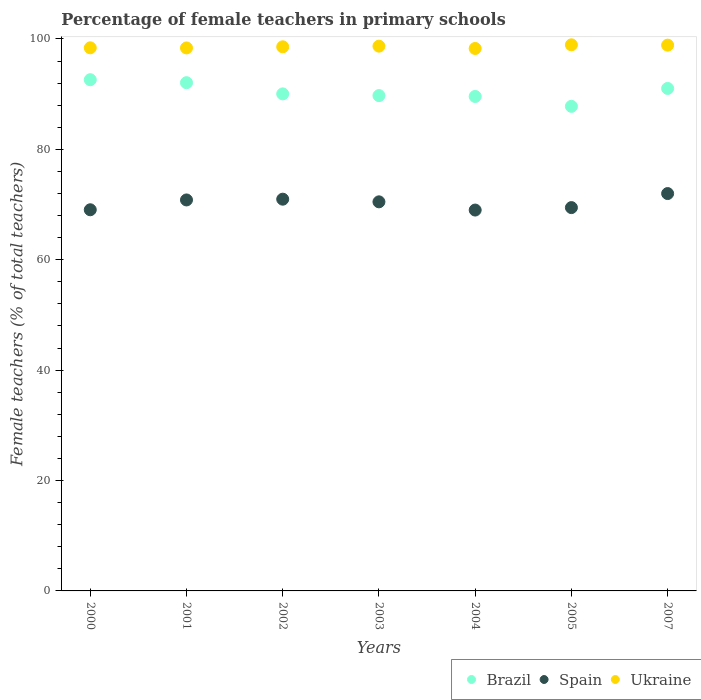How many different coloured dotlines are there?
Keep it short and to the point. 3. What is the percentage of female teachers in Brazil in 2002?
Offer a terse response. 90.04. Across all years, what is the maximum percentage of female teachers in Ukraine?
Offer a very short reply. 98.93. Across all years, what is the minimum percentage of female teachers in Brazil?
Provide a succinct answer. 87.79. In which year was the percentage of female teachers in Ukraine minimum?
Provide a succinct answer. 2004. What is the total percentage of female teachers in Brazil in the graph?
Make the answer very short. 632.86. What is the difference between the percentage of female teachers in Brazil in 2002 and that in 2003?
Provide a short and direct response. 0.31. What is the difference between the percentage of female teachers in Spain in 2004 and the percentage of female teachers in Ukraine in 2001?
Provide a short and direct response. -29.37. What is the average percentage of female teachers in Brazil per year?
Ensure brevity in your answer.  90.41. In the year 2004, what is the difference between the percentage of female teachers in Brazil and percentage of female teachers in Ukraine?
Your response must be concise. -8.69. What is the ratio of the percentage of female teachers in Brazil in 2005 to that in 2007?
Offer a very short reply. 0.96. Is the percentage of female teachers in Spain in 2002 less than that in 2004?
Offer a very short reply. No. What is the difference between the highest and the second highest percentage of female teachers in Brazil?
Your response must be concise. 0.54. What is the difference between the highest and the lowest percentage of female teachers in Spain?
Provide a short and direct response. 2.99. In how many years, is the percentage of female teachers in Spain greater than the average percentage of female teachers in Spain taken over all years?
Provide a succinct answer. 4. Is it the case that in every year, the sum of the percentage of female teachers in Spain and percentage of female teachers in Ukraine  is greater than the percentage of female teachers in Brazil?
Ensure brevity in your answer.  Yes. Is the percentage of female teachers in Spain strictly less than the percentage of female teachers in Brazil over the years?
Your response must be concise. Yes. What is the difference between two consecutive major ticks on the Y-axis?
Give a very brief answer. 20. Are the values on the major ticks of Y-axis written in scientific E-notation?
Provide a succinct answer. No. Does the graph contain any zero values?
Keep it short and to the point. No. How are the legend labels stacked?
Your answer should be compact. Horizontal. What is the title of the graph?
Make the answer very short. Percentage of female teachers in primary schools. Does "Cameroon" appear as one of the legend labels in the graph?
Keep it short and to the point. No. What is the label or title of the Y-axis?
Your answer should be very brief. Female teachers (% of total teachers). What is the Female teachers (% of total teachers) in Brazil in 2000?
Make the answer very short. 92.61. What is the Female teachers (% of total teachers) in Spain in 2000?
Keep it short and to the point. 69.05. What is the Female teachers (% of total teachers) of Ukraine in 2000?
Your answer should be very brief. 98.39. What is the Female teachers (% of total teachers) of Brazil in 2001?
Provide a succinct answer. 92.07. What is the Female teachers (% of total teachers) in Spain in 2001?
Provide a short and direct response. 70.83. What is the Female teachers (% of total teachers) of Ukraine in 2001?
Make the answer very short. 98.37. What is the Female teachers (% of total teachers) in Brazil in 2002?
Provide a short and direct response. 90.04. What is the Female teachers (% of total teachers) in Spain in 2002?
Give a very brief answer. 70.97. What is the Female teachers (% of total teachers) of Ukraine in 2002?
Your response must be concise. 98.57. What is the Female teachers (% of total teachers) in Brazil in 2003?
Your answer should be compact. 89.73. What is the Female teachers (% of total teachers) of Spain in 2003?
Provide a short and direct response. 70.49. What is the Female teachers (% of total teachers) in Ukraine in 2003?
Make the answer very short. 98.69. What is the Female teachers (% of total teachers) of Brazil in 2004?
Your answer should be very brief. 89.58. What is the Female teachers (% of total teachers) in Spain in 2004?
Provide a short and direct response. 69. What is the Female teachers (% of total teachers) of Ukraine in 2004?
Make the answer very short. 98.27. What is the Female teachers (% of total teachers) in Brazil in 2005?
Your response must be concise. 87.79. What is the Female teachers (% of total teachers) in Spain in 2005?
Your response must be concise. 69.44. What is the Female teachers (% of total teachers) of Ukraine in 2005?
Offer a terse response. 98.93. What is the Female teachers (% of total teachers) of Brazil in 2007?
Ensure brevity in your answer.  91.03. What is the Female teachers (% of total teachers) of Spain in 2007?
Provide a succinct answer. 71.99. What is the Female teachers (% of total teachers) of Ukraine in 2007?
Keep it short and to the point. 98.87. Across all years, what is the maximum Female teachers (% of total teachers) in Brazil?
Your answer should be compact. 92.61. Across all years, what is the maximum Female teachers (% of total teachers) in Spain?
Your response must be concise. 71.99. Across all years, what is the maximum Female teachers (% of total teachers) of Ukraine?
Offer a terse response. 98.93. Across all years, what is the minimum Female teachers (% of total teachers) of Brazil?
Ensure brevity in your answer.  87.79. Across all years, what is the minimum Female teachers (% of total teachers) in Spain?
Offer a very short reply. 69. Across all years, what is the minimum Female teachers (% of total teachers) of Ukraine?
Your answer should be compact. 98.27. What is the total Female teachers (% of total teachers) of Brazil in the graph?
Your answer should be very brief. 632.86. What is the total Female teachers (% of total teachers) in Spain in the graph?
Provide a short and direct response. 491.76. What is the total Female teachers (% of total teachers) of Ukraine in the graph?
Your response must be concise. 690.09. What is the difference between the Female teachers (% of total teachers) of Brazil in 2000 and that in 2001?
Ensure brevity in your answer.  0.54. What is the difference between the Female teachers (% of total teachers) in Spain in 2000 and that in 2001?
Make the answer very short. -1.78. What is the difference between the Female teachers (% of total teachers) in Ukraine in 2000 and that in 2001?
Ensure brevity in your answer.  0.02. What is the difference between the Female teachers (% of total teachers) of Brazil in 2000 and that in 2002?
Ensure brevity in your answer.  2.57. What is the difference between the Female teachers (% of total teachers) of Spain in 2000 and that in 2002?
Keep it short and to the point. -1.92. What is the difference between the Female teachers (% of total teachers) of Ukraine in 2000 and that in 2002?
Your answer should be very brief. -0.18. What is the difference between the Female teachers (% of total teachers) in Brazil in 2000 and that in 2003?
Make the answer very short. 2.88. What is the difference between the Female teachers (% of total teachers) in Spain in 2000 and that in 2003?
Offer a terse response. -1.44. What is the difference between the Female teachers (% of total teachers) in Ukraine in 2000 and that in 2003?
Ensure brevity in your answer.  -0.3. What is the difference between the Female teachers (% of total teachers) in Brazil in 2000 and that in 2004?
Offer a terse response. 3.03. What is the difference between the Female teachers (% of total teachers) of Spain in 2000 and that in 2004?
Keep it short and to the point. 0.05. What is the difference between the Female teachers (% of total teachers) of Ukraine in 2000 and that in 2004?
Your response must be concise. 0.12. What is the difference between the Female teachers (% of total teachers) of Brazil in 2000 and that in 2005?
Your answer should be very brief. 4.83. What is the difference between the Female teachers (% of total teachers) of Spain in 2000 and that in 2005?
Make the answer very short. -0.39. What is the difference between the Female teachers (% of total teachers) of Ukraine in 2000 and that in 2005?
Keep it short and to the point. -0.54. What is the difference between the Female teachers (% of total teachers) of Brazil in 2000 and that in 2007?
Offer a terse response. 1.58. What is the difference between the Female teachers (% of total teachers) of Spain in 2000 and that in 2007?
Offer a terse response. -2.94. What is the difference between the Female teachers (% of total teachers) of Ukraine in 2000 and that in 2007?
Offer a very short reply. -0.48. What is the difference between the Female teachers (% of total teachers) in Brazil in 2001 and that in 2002?
Make the answer very short. 2.03. What is the difference between the Female teachers (% of total teachers) of Spain in 2001 and that in 2002?
Provide a short and direct response. -0.14. What is the difference between the Female teachers (% of total teachers) of Ukraine in 2001 and that in 2002?
Make the answer very short. -0.2. What is the difference between the Female teachers (% of total teachers) of Brazil in 2001 and that in 2003?
Provide a short and direct response. 2.34. What is the difference between the Female teachers (% of total teachers) in Spain in 2001 and that in 2003?
Provide a short and direct response. 0.34. What is the difference between the Female teachers (% of total teachers) in Ukraine in 2001 and that in 2003?
Your answer should be compact. -0.32. What is the difference between the Female teachers (% of total teachers) of Brazil in 2001 and that in 2004?
Give a very brief answer. 2.49. What is the difference between the Female teachers (% of total teachers) of Spain in 2001 and that in 2004?
Provide a short and direct response. 1.83. What is the difference between the Female teachers (% of total teachers) of Ukraine in 2001 and that in 2004?
Offer a terse response. 0.1. What is the difference between the Female teachers (% of total teachers) in Brazil in 2001 and that in 2005?
Offer a very short reply. 4.28. What is the difference between the Female teachers (% of total teachers) in Spain in 2001 and that in 2005?
Make the answer very short. 1.39. What is the difference between the Female teachers (% of total teachers) of Ukraine in 2001 and that in 2005?
Keep it short and to the point. -0.56. What is the difference between the Female teachers (% of total teachers) in Brazil in 2001 and that in 2007?
Keep it short and to the point. 1.04. What is the difference between the Female teachers (% of total teachers) in Spain in 2001 and that in 2007?
Give a very brief answer. -1.16. What is the difference between the Female teachers (% of total teachers) in Ukraine in 2001 and that in 2007?
Provide a short and direct response. -0.5. What is the difference between the Female teachers (% of total teachers) of Brazil in 2002 and that in 2003?
Provide a short and direct response. 0.31. What is the difference between the Female teachers (% of total teachers) of Spain in 2002 and that in 2003?
Provide a succinct answer. 0.48. What is the difference between the Female teachers (% of total teachers) of Ukraine in 2002 and that in 2003?
Give a very brief answer. -0.12. What is the difference between the Female teachers (% of total teachers) of Brazil in 2002 and that in 2004?
Offer a terse response. 0.47. What is the difference between the Female teachers (% of total teachers) in Spain in 2002 and that in 2004?
Offer a very short reply. 1.97. What is the difference between the Female teachers (% of total teachers) of Ukraine in 2002 and that in 2004?
Provide a succinct answer. 0.3. What is the difference between the Female teachers (% of total teachers) in Brazil in 2002 and that in 2005?
Your answer should be compact. 2.26. What is the difference between the Female teachers (% of total teachers) of Spain in 2002 and that in 2005?
Your answer should be very brief. 1.53. What is the difference between the Female teachers (% of total teachers) in Ukraine in 2002 and that in 2005?
Provide a succinct answer. -0.36. What is the difference between the Female teachers (% of total teachers) in Brazil in 2002 and that in 2007?
Give a very brief answer. -0.99. What is the difference between the Female teachers (% of total teachers) of Spain in 2002 and that in 2007?
Give a very brief answer. -1.02. What is the difference between the Female teachers (% of total teachers) in Ukraine in 2002 and that in 2007?
Provide a short and direct response. -0.3. What is the difference between the Female teachers (% of total teachers) in Brazil in 2003 and that in 2004?
Ensure brevity in your answer.  0.16. What is the difference between the Female teachers (% of total teachers) of Spain in 2003 and that in 2004?
Your answer should be compact. 1.49. What is the difference between the Female teachers (% of total teachers) of Ukraine in 2003 and that in 2004?
Your response must be concise. 0.42. What is the difference between the Female teachers (% of total teachers) of Brazil in 2003 and that in 2005?
Give a very brief answer. 1.95. What is the difference between the Female teachers (% of total teachers) of Spain in 2003 and that in 2005?
Your answer should be compact. 1.04. What is the difference between the Female teachers (% of total teachers) in Ukraine in 2003 and that in 2005?
Give a very brief answer. -0.24. What is the difference between the Female teachers (% of total teachers) in Brazil in 2003 and that in 2007?
Your response must be concise. -1.3. What is the difference between the Female teachers (% of total teachers) of Spain in 2003 and that in 2007?
Offer a terse response. -1.5. What is the difference between the Female teachers (% of total teachers) in Ukraine in 2003 and that in 2007?
Keep it short and to the point. -0.18. What is the difference between the Female teachers (% of total teachers) of Brazil in 2004 and that in 2005?
Your response must be concise. 1.79. What is the difference between the Female teachers (% of total teachers) of Spain in 2004 and that in 2005?
Your answer should be very brief. -0.45. What is the difference between the Female teachers (% of total teachers) in Ukraine in 2004 and that in 2005?
Give a very brief answer. -0.66. What is the difference between the Female teachers (% of total teachers) of Brazil in 2004 and that in 2007?
Ensure brevity in your answer.  -1.45. What is the difference between the Female teachers (% of total teachers) in Spain in 2004 and that in 2007?
Offer a terse response. -2.99. What is the difference between the Female teachers (% of total teachers) in Ukraine in 2004 and that in 2007?
Give a very brief answer. -0.6. What is the difference between the Female teachers (% of total teachers) of Brazil in 2005 and that in 2007?
Ensure brevity in your answer.  -3.24. What is the difference between the Female teachers (% of total teachers) of Spain in 2005 and that in 2007?
Ensure brevity in your answer.  -2.54. What is the difference between the Female teachers (% of total teachers) of Ukraine in 2005 and that in 2007?
Offer a terse response. 0.06. What is the difference between the Female teachers (% of total teachers) of Brazil in 2000 and the Female teachers (% of total teachers) of Spain in 2001?
Ensure brevity in your answer.  21.78. What is the difference between the Female teachers (% of total teachers) in Brazil in 2000 and the Female teachers (% of total teachers) in Ukraine in 2001?
Offer a terse response. -5.76. What is the difference between the Female teachers (% of total teachers) in Spain in 2000 and the Female teachers (% of total teachers) in Ukraine in 2001?
Your answer should be compact. -29.32. What is the difference between the Female teachers (% of total teachers) of Brazil in 2000 and the Female teachers (% of total teachers) of Spain in 2002?
Give a very brief answer. 21.64. What is the difference between the Female teachers (% of total teachers) in Brazil in 2000 and the Female teachers (% of total teachers) in Ukraine in 2002?
Offer a very short reply. -5.96. What is the difference between the Female teachers (% of total teachers) of Spain in 2000 and the Female teachers (% of total teachers) of Ukraine in 2002?
Provide a short and direct response. -29.52. What is the difference between the Female teachers (% of total teachers) of Brazil in 2000 and the Female teachers (% of total teachers) of Spain in 2003?
Ensure brevity in your answer.  22.13. What is the difference between the Female teachers (% of total teachers) of Brazil in 2000 and the Female teachers (% of total teachers) of Ukraine in 2003?
Provide a succinct answer. -6.08. What is the difference between the Female teachers (% of total teachers) of Spain in 2000 and the Female teachers (% of total teachers) of Ukraine in 2003?
Make the answer very short. -29.64. What is the difference between the Female teachers (% of total teachers) of Brazil in 2000 and the Female teachers (% of total teachers) of Spain in 2004?
Your answer should be very brief. 23.62. What is the difference between the Female teachers (% of total teachers) in Brazil in 2000 and the Female teachers (% of total teachers) in Ukraine in 2004?
Ensure brevity in your answer.  -5.66. What is the difference between the Female teachers (% of total teachers) of Spain in 2000 and the Female teachers (% of total teachers) of Ukraine in 2004?
Give a very brief answer. -29.22. What is the difference between the Female teachers (% of total teachers) in Brazil in 2000 and the Female teachers (% of total teachers) in Spain in 2005?
Your response must be concise. 23.17. What is the difference between the Female teachers (% of total teachers) of Brazil in 2000 and the Female teachers (% of total teachers) of Ukraine in 2005?
Provide a succinct answer. -6.32. What is the difference between the Female teachers (% of total teachers) in Spain in 2000 and the Female teachers (% of total teachers) in Ukraine in 2005?
Offer a terse response. -29.88. What is the difference between the Female teachers (% of total teachers) of Brazil in 2000 and the Female teachers (% of total teachers) of Spain in 2007?
Your answer should be very brief. 20.63. What is the difference between the Female teachers (% of total teachers) of Brazil in 2000 and the Female teachers (% of total teachers) of Ukraine in 2007?
Offer a terse response. -6.26. What is the difference between the Female teachers (% of total teachers) in Spain in 2000 and the Female teachers (% of total teachers) in Ukraine in 2007?
Make the answer very short. -29.82. What is the difference between the Female teachers (% of total teachers) in Brazil in 2001 and the Female teachers (% of total teachers) in Spain in 2002?
Make the answer very short. 21.1. What is the difference between the Female teachers (% of total teachers) in Brazil in 2001 and the Female teachers (% of total teachers) in Ukraine in 2002?
Your response must be concise. -6.5. What is the difference between the Female teachers (% of total teachers) in Spain in 2001 and the Female teachers (% of total teachers) in Ukraine in 2002?
Offer a very short reply. -27.74. What is the difference between the Female teachers (% of total teachers) in Brazil in 2001 and the Female teachers (% of total teachers) in Spain in 2003?
Ensure brevity in your answer.  21.59. What is the difference between the Female teachers (% of total teachers) in Brazil in 2001 and the Female teachers (% of total teachers) in Ukraine in 2003?
Your answer should be very brief. -6.62. What is the difference between the Female teachers (% of total teachers) of Spain in 2001 and the Female teachers (% of total teachers) of Ukraine in 2003?
Your answer should be compact. -27.86. What is the difference between the Female teachers (% of total teachers) in Brazil in 2001 and the Female teachers (% of total teachers) in Spain in 2004?
Keep it short and to the point. 23.07. What is the difference between the Female teachers (% of total teachers) in Brazil in 2001 and the Female teachers (% of total teachers) in Ukraine in 2004?
Offer a very short reply. -6.2. What is the difference between the Female teachers (% of total teachers) of Spain in 2001 and the Female teachers (% of total teachers) of Ukraine in 2004?
Make the answer very short. -27.44. What is the difference between the Female teachers (% of total teachers) of Brazil in 2001 and the Female teachers (% of total teachers) of Spain in 2005?
Provide a succinct answer. 22.63. What is the difference between the Female teachers (% of total teachers) in Brazil in 2001 and the Female teachers (% of total teachers) in Ukraine in 2005?
Keep it short and to the point. -6.86. What is the difference between the Female teachers (% of total teachers) in Spain in 2001 and the Female teachers (% of total teachers) in Ukraine in 2005?
Offer a very short reply. -28.1. What is the difference between the Female teachers (% of total teachers) in Brazil in 2001 and the Female teachers (% of total teachers) in Spain in 2007?
Provide a short and direct response. 20.09. What is the difference between the Female teachers (% of total teachers) of Brazil in 2001 and the Female teachers (% of total teachers) of Ukraine in 2007?
Your answer should be compact. -6.8. What is the difference between the Female teachers (% of total teachers) in Spain in 2001 and the Female teachers (% of total teachers) in Ukraine in 2007?
Ensure brevity in your answer.  -28.04. What is the difference between the Female teachers (% of total teachers) in Brazil in 2002 and the Female teachers (% of total teachers) in Spain in 2003?
Provide a succinct answer. 19.56. What is the difference between the Female teachers (% of total teachers) in Brazil in 2002 and the Female teachers (% of total teachers) in Ukraine in 2003?
Your answer should be compact. -8.65. What is the difference between the Female teachers (% of total teachers) in Spain in 2002 and the Female teachers (% of total teachers) in Ukraine in 2003?
Your answer should be very brief. -27.72. What is the difference between the Female teachers (% of total teachers) in Brazil in 2002 and the Female teachers (% of total teachers) in Spain in 2004?
Provide a succinct answer. 21.05. What is the difference between the Female teachers (% of total teachers) of Brazil in 2002 and the Female teachers (% of total teachers) of Ukraine in 2004?
Your answer should be very brief. -8.22. What is the difference between the Female teachers (% of total teachers) of Spain in 2002 and the Female teachers (% of total teachers) of Ukraine in 2004?
Offer a terse response. -27.3. What is the difference between the Female teachers (% of total teachers) of Brazil in 2002 and the Female teachers (% of total teachers) of Spain in 2005?
Keep it short and to the point. 20.6. What is the difference between the Female teachers (% of total teachers) of Brazil in 2002 and the Female teachers (% of total teachers) of Ukraine in 2005?
Ensure brevity in your answer.  -8.88. What is the difference between the Female teachers (% of total teachers) in Spain in 2002 and the Female teachers (% of total teachers) in Ukraine in 2005?
Offer a terse response. -27.96. What is the difference between the Female teachers (% of total teachers) in Brazil in 2002 and the Female teachers (% of total teachers) in Spain in 2007?
Offer a terse response. 18.06. What is the difference between the Female teachers (% of total teachers) in Brazil in 2002 and the Female teachers (% of total teachers) in Ukraine in 2007?
Your answer should be very brief. -8.83. What is the difference between the Female teachers (% of total teachers) in Spain in 2002 and the Female teachers (% of total teachers) in Ukraine in 2007?
Your answer should be compact. -27.9. What is the difference between the Female teachers (% of total teachers) in Brazil in 2003 and the Female teachers (% of total teachers) in Spain in 2004?
Offer a terse response. 20.74. What is the difference between the Female teachers (% of total teachers) of Brazil in 2003 and the Female teachers (% of total teachers) of Ukraine in 2004?
Your response must be concise. -8.54. What is the difference between the Female teachers (% of total teachers) of Spain in 2003 and the Female teachers (% of total teachers) of Ukraine in 2004?
Provide a succinct answer. -27.78. What is the difference between the Female teachers (% of total teachers) in Brazil in 2003 and the Female teachers (% of total teachers) in Spain in 2005?
Your answer should be very brief. 20.29. What is the difference between the Female teachers (% of total teachers) in Brazil in 2003 and the Female teachers (% of total teachers) in Ukraine in 2005?
Your answer should be very brief. -9.19. What is the difference between the Female teachers (% of total teachers) in Spain in 2003 and the Female teachers (% of total teachers) in Ukraine in 2005?
Keep it short and to the point. -28.44. What is the difference between the Female teachers (% of total teachers) of Brazil in 2003 and the Female teachers (% of total teachers) of Spain in 2007?
Give a very brief answer. 17.75. What is the difference between the Female teachers (% of total teachers) in Brazil in 2003 and the Female teachers (% of total teachers) in Ukraine in 2007?
Keep it short and to the point. -9.14. What is the difference between the Female teachers (% of total teachers) in Spain in 2003 and the Female teachers (% of total teachers) in Ukraine in 2007?
Offer a terse response. -28.39. What is the difference between the Female teachers (% of total teachers) of Brazil in 2004 and the Female teachers (% of total teachers) of Spain in 2005?
Your answer should be compact. 20.14. What is the difference between the Female teachers (% of total teachers) in Brazil in 2004 and the Female teachers (% of total teachers) in Ukraine in 2005?
Make the answer very short. -9.35. What is the difference between the Female teachers (% of total teachers) in Spain in 2004 and the Female teachers (% of total teachers) in Ukraine in 2005?
Give a very brief answer. -29.93. What is the difference between the Female teachers (% of total teachers) of Brazil in 2004 and the Female teachers (% of total teachers) of Spain in 2007?
Provide a succinct answer. 17.59. What is the difference between the Female teachers (% of total teachers) of Brazil in 2004 and the Female teachers (% of total teachers) of Ukraine in 2007?
Offer a very short reply. -9.29. What is the difference between the Female teachers (% of total teachers) in Spain in 2004 and the Female teachers (% of total teachers) in Ukraine in 2007?
Offer a terse response. -29.87. What is the difference between the Female teachers (% of total teachers) in Brazil in 2005 and the Female teachers (% of total teachers) in Spain in 2007?
Give a very brief answer. 15.8. What is the difference between the Female teachers (% of total teachers) in Brazil in 2005 and the Female teachers (% of total teachers) in Ukraine in 2007?
Provide a short and direct response. -11.08. What is the difference between the Female teachers (% of total teachers) of Spain in 2005 and the Female teachers (% of total teachers) of Ukraine in 2007?
Offer a very short reply. -29.43. What is the average Female teachers (% of total teachers) in Brazil per year?
Your response must be concise. 90.41. What is the average Female teachers (% of total teachers) in Spain per year?
Ensure brevity in your answer.  70.25. What is the average Female teachers (% of total teachers) in Ukraine per year?
Keep it short and to the point. 98.58. In the year 2000, what is the difference between the Female teachers (% of total teachers) in Brazil and Female teachers (% of total teachers) in Spain?
Provide a succinct answer. 23.56. In the year 2000, what is the difference between the Female teachers (% of total teachers) of Brazil and Female teachers (% of total teachers) of Ukraine?
Provide a succinct answer. -5.78. In the year 2000, what is the difference between the Female teachers (% of total teachers) of Spain and Female teachers (% of total teachers) of Ukraine?
Keep it short and to the point. -29.34. In the year 2001, what is the difference between the Female teachers (% of total teachers) of Brazil and Female teachers (% of total teachers) of Spain?
Your answer should be compact. 21.24. In the year 2001, what is the difference between the Female teachers (% of total teachers) of Brazil and Female teachers (% of total teachers) of Ukraine?
Provide a succinct answer. -6.3. In the year 2001, what is the difference between the Female teachers (% of total teachers) of Spain and Female teachers (% of total teachers) of Ukraine?
Provide a short and direct response. -27.54. In the year 2002, what is the difference between the Female teachers (% of total teachers) of Brazil and Female teachers (% of total teachers) of Spain?
Provide a short and direct response. 19.08. In the year 2002, what is the difference between the Female teachers (% of total teachers) of Brazil and Female teachers (% of total teachers) of Ukraine?
Your answer should be very brief. -8.52. In the year 2002, what is the difference between the Female teachers (% of total teachers) in Spain and Female teachers (% of total teachers) in Ukraine?
Make the answer very short. -27.6. In the year 2003, what is the difference between the Female teachers (% of total teachers) of Brazil and Female teachers (% of total teachers) of Spain?
Make the answer very short. 19.25. In the year 2003, what is the difference between the Female teachers (% of total teachers) in Brazil and Female teachers (% of total teachers) in Ukraine?
Your answer should be compact. -8.96. In the year 2003, what is the difference between the Female teachers (% of total teachers) of Spain and Female teachers (% of total teachers) of Ukraine?
Offer a very short reply. -28.2. In the year 2004, what is the difference between the Female teachers (% of total teachers) of Brazil and Female teachers (% of total teachers) of Spain?
Offer a terse response. 20.58. In the year 2004, what is the difference between the Female teachers (% of total teachers) in Brazil and Female teachers (% of total teachers) in Ukraine?
Provide a short and direct response. -8.69. In the year 2004, what is the difference between the Female teachers (% of total teachers) of Spain and Female teachers (% of total teachers) of Ukraine?
Provide a short and direct response. -29.27. In the year 2005, what is the difference between the Female teachers (% of total teachers) in Brazil and Female teachers (% of total teachers) in Spain?
Your response must be concise. 18.34. In the year 2005, what is the difference between the Female teachers (% of total teachers) in Brazil and Female teachers (% of total teachers) in Ukraine?
Make the answer very short. -11.14. In the year 2005, what is the difference between the Female teachers (% of total teachers) of Spain and Female teachers (% of total teachers) of Ukraine?
Give a very brief answer. -29.49. In the year 2007, what is the difference between the Female teachers (% of total teachers) in Brazil and Female teachers (% of total teachers) in Spain?
Provide a succinct answer. 19.04. In the year 2007, what is the difference between the Female teachers (% of total teachers) in Brazil and Female teachers (% of total teachers) in Ukraine?
Give a very brief answer. -7.84. In the year 2007, what is the difference between the Female teachers (% of total teachers) in Spain and Female teachers (% of total teachers) in Ukraine?
Keep it short and to the point. -26.89. What is the ratio of the Female teachers (% of total teachers) of Brazil in 2000 to that in 2001?
Your answer should be compact. 1.01. What is the ratio of the Female teachers (% of total teachers) of Spain in 2000 to that in 2001?
Your response must be concise. 0.97. What is the ratio of the Female teachers (% of total teachers) of Ukraine in 2000 to that in 2001?
Make the answer very short. 1. What is the ratio of the Female teachers (% of total teachers) of Brazil in 2000 to that in 2002?
Ensure brevity in your answer.  1.03. What is the ratio of the Female teachers (% of total teachers) in Spain in 2000 to that in 2002?
Ensure brevity in your answer.  0.97. What is the ratio of the Female teachers (% of total teachers) of Brazil in 2000 to that in 2003?
Give a very brief answer. 1.03. What is the ratio of the Female teachers (% of total teachers) of Spain in 2000 to that in 2003?
Offer a terse response. 0.98. What is the ratio of the Female teachers (% of total teachers) in Brazil in 2000 to that in 2004?
Keep it short and to the point. 1.03. What is the ratio of the Female teachers (% of total teachers) of Ukraine in 2000 to that in 2004?
Provide a succinct answer. 1. What is the ratio of the Female teachers (% of total teachers) in Brazil in 2000 to that in 2005?
Offer a terse response. 1.05. What is the ratio of the Female teachers (% of total teachers) in Spain in 2000 to that in 2005?
Offer a terse response. 0.99. What is the ratio of the Female teachers (% of total teachers) of Brazil in 2000 to that in 2007?
Offer a terse response. 1.02. What is the ratio of the Female teachers (% of total teachers) of Spain in 2000 to that in 2007?
Ensure brevity in your answer.  0.96. What is the ratio of the Female teachers (% of total teachers) in Ukraine in 2000 to that in 2007?
Give a very brief answer. 1. What is the ratio of the Female teachers (% of total teachers) of Brazil in 2001 to that in 2002?
Your answer should be compact. 1.02. What is the ratio of the Female teachers (% of total teachers) in Ukraine in 2001 to that in 2002?
Make the answer very short. 1. What is the ratio of the Female teachers (% of total teachers) of Brazil in 2001 to that in 2003?
Your answer should be compact. 1.03. What is the ratio of the Female teachers (% of total teachers) of Ukraine in 2001 to that in 2003?
Make the answer very short. 1. What is the ratio of the Female teachers (% of total teachers) of Brazil in 2001 to that in 2004?
Provide a succinct answer. 1.03. What is the ratio of the Female teachers (% of total teachers) of Spain in 2001 to that in 2004?
Make the answer very short. 1.03. What is the ratio of the Female teachers (% of total teachers) in Brazil in 2001 to that in 2005?
Ensure brevity in your answer.  1.05. What is the ratio of the Female teachers (% of total teachers) in Ukraine in 2001 to that in 2005?
Make the answer very short. 0.99. What is the ratio of the Female teachers (% of total teachers) in Brazil in 2001 to that in 2007?
Make the answer very short. 1.01. What is the ratio of the Female teachers (% of total teachers) of Spain in 2001 to that in 2007?
Your answer should be very brief. 0.98. What is the ratio of the Female teachers (% of total teachers) in Brazil in 2002 to that in 2003?
Make the answer very short. 1. What is the ratio of the Female teachers (% of total teachers) of Spain in 2002 to that in 2003?
Give a very brief answer. 1.01. What is the ratio of the Female teachers (% of total teachers) in Ukraine in 2002 to that in 2003?
Give a very brief answer. 1. What is the ratio of the Female teachers (% of total teachers) in Brazil in 2002 to that in 2004?
Your response must be concise. 1.01. What is the ratio of the Female teachers (% of total teachers) of Spain in 2002 to that in 2004?
Give a very brief answer. 1.03. What is the ratio of the Female teachers (% of total teachers) in Brazil in 2002 to that in 2005?
Ensure brevity in your answer.  1.03. What is the ratio of the Female teachers (% of total teachers) of Spain in 2002 to that in 2005?
Your answer should be very brief. 1.02. What is the ratio of the Female teachers (% of total teachers) in Ukraine in 2002 to that in 2005?
Ensure brevity in your answer.  1. What is the ratio of the Female teachers (% of total teachers) of Spain in 2002 to that in 2007?
Your answer should be compact. 0.99. What is the ratio of the Female teachers (% of total teachers) in Spain in 2003 to that in 2004?
Give a very brief answer. 1.02. What is the ratio of the Female teachers (% of total teachers) of Brazil in 2003 to that in 2005?
Keep it short and to the point. 1.02. What is the ratio of the Female teachers (% of total teachers) in Spain in 2003 to that in 2005?
Provide a short and direct response. 1.01. What is the ratio of the Female teachers (% of total teachers) of Brazil in 2003 to that in 2007?
Offer a very short reply. 0.99. What is the ratio of the Female teachers (% of total teachers) of Spain in 2003 to that in 2007?
Offer a terse response. 0.98. What is the ratio of the Female teachers (% of total teachers) in Ukraine in 2003 to that in 2007?
Offer a terse response. 1. What is the ratio of the Female teachers (% of total teachers) of Brazil in 2004 to that in 2005?
Provide a succinct answer. 1.02. What is the ratio of the Female teachers (% of total teachers) of Spain in 2004 to that in 2005?
Make the answer very short. 0.99. What is the ratio of the Female teachers (% of total teachers) in Ukraine in 2004 to that in 2005?
Your answer should be very brief. 0.99. What is the ratio of the Female teachers (% of total teachers) of Brazil in 2004 to that in 2007?
Your answer should be very brief. 0.98. What is the ratio of the Female teachers (% of total teachers) in Spain in 2004 to that in 2007?
Your answer should be compact. 0.96. What is the ratio of the Female teachers (% of total teachers) of Brazil in 2005 to that in 2007?
Ensure brevity in your answer.  0.96. What is the ratio of the Female teachers (% of total teachers) in Spain in 2005 to that in 2007?
Ensure brevity in your answer.  0.96. What is the difference between the highest and the second highest Female teachers (% of total teachers) of Brazil?
Offer a terse response. 0.54. What is the difference between the highest and the second highest Female teachers (% of total teachers) in Spain?
Your answer should be very brief. 1.02. What is the difference between the highest and the second highest Female teachers (% of total teachers) of Ukraine?
Your answer should be compact. 0.06. What is the difference between the highest and the lowest Female teachers (% of total teachers) in Brazil?
Ensure brevity in your answer.  4.83. What is the difference between the highest and the lowest Female teachers (% of total teachers) in Spain?
Your answer should be very brief. 2.99. What is the difference between the highest and the lowest Female teachers (% of total teachers) in Ukraine?
Keep it short and to the point. 0.66. 